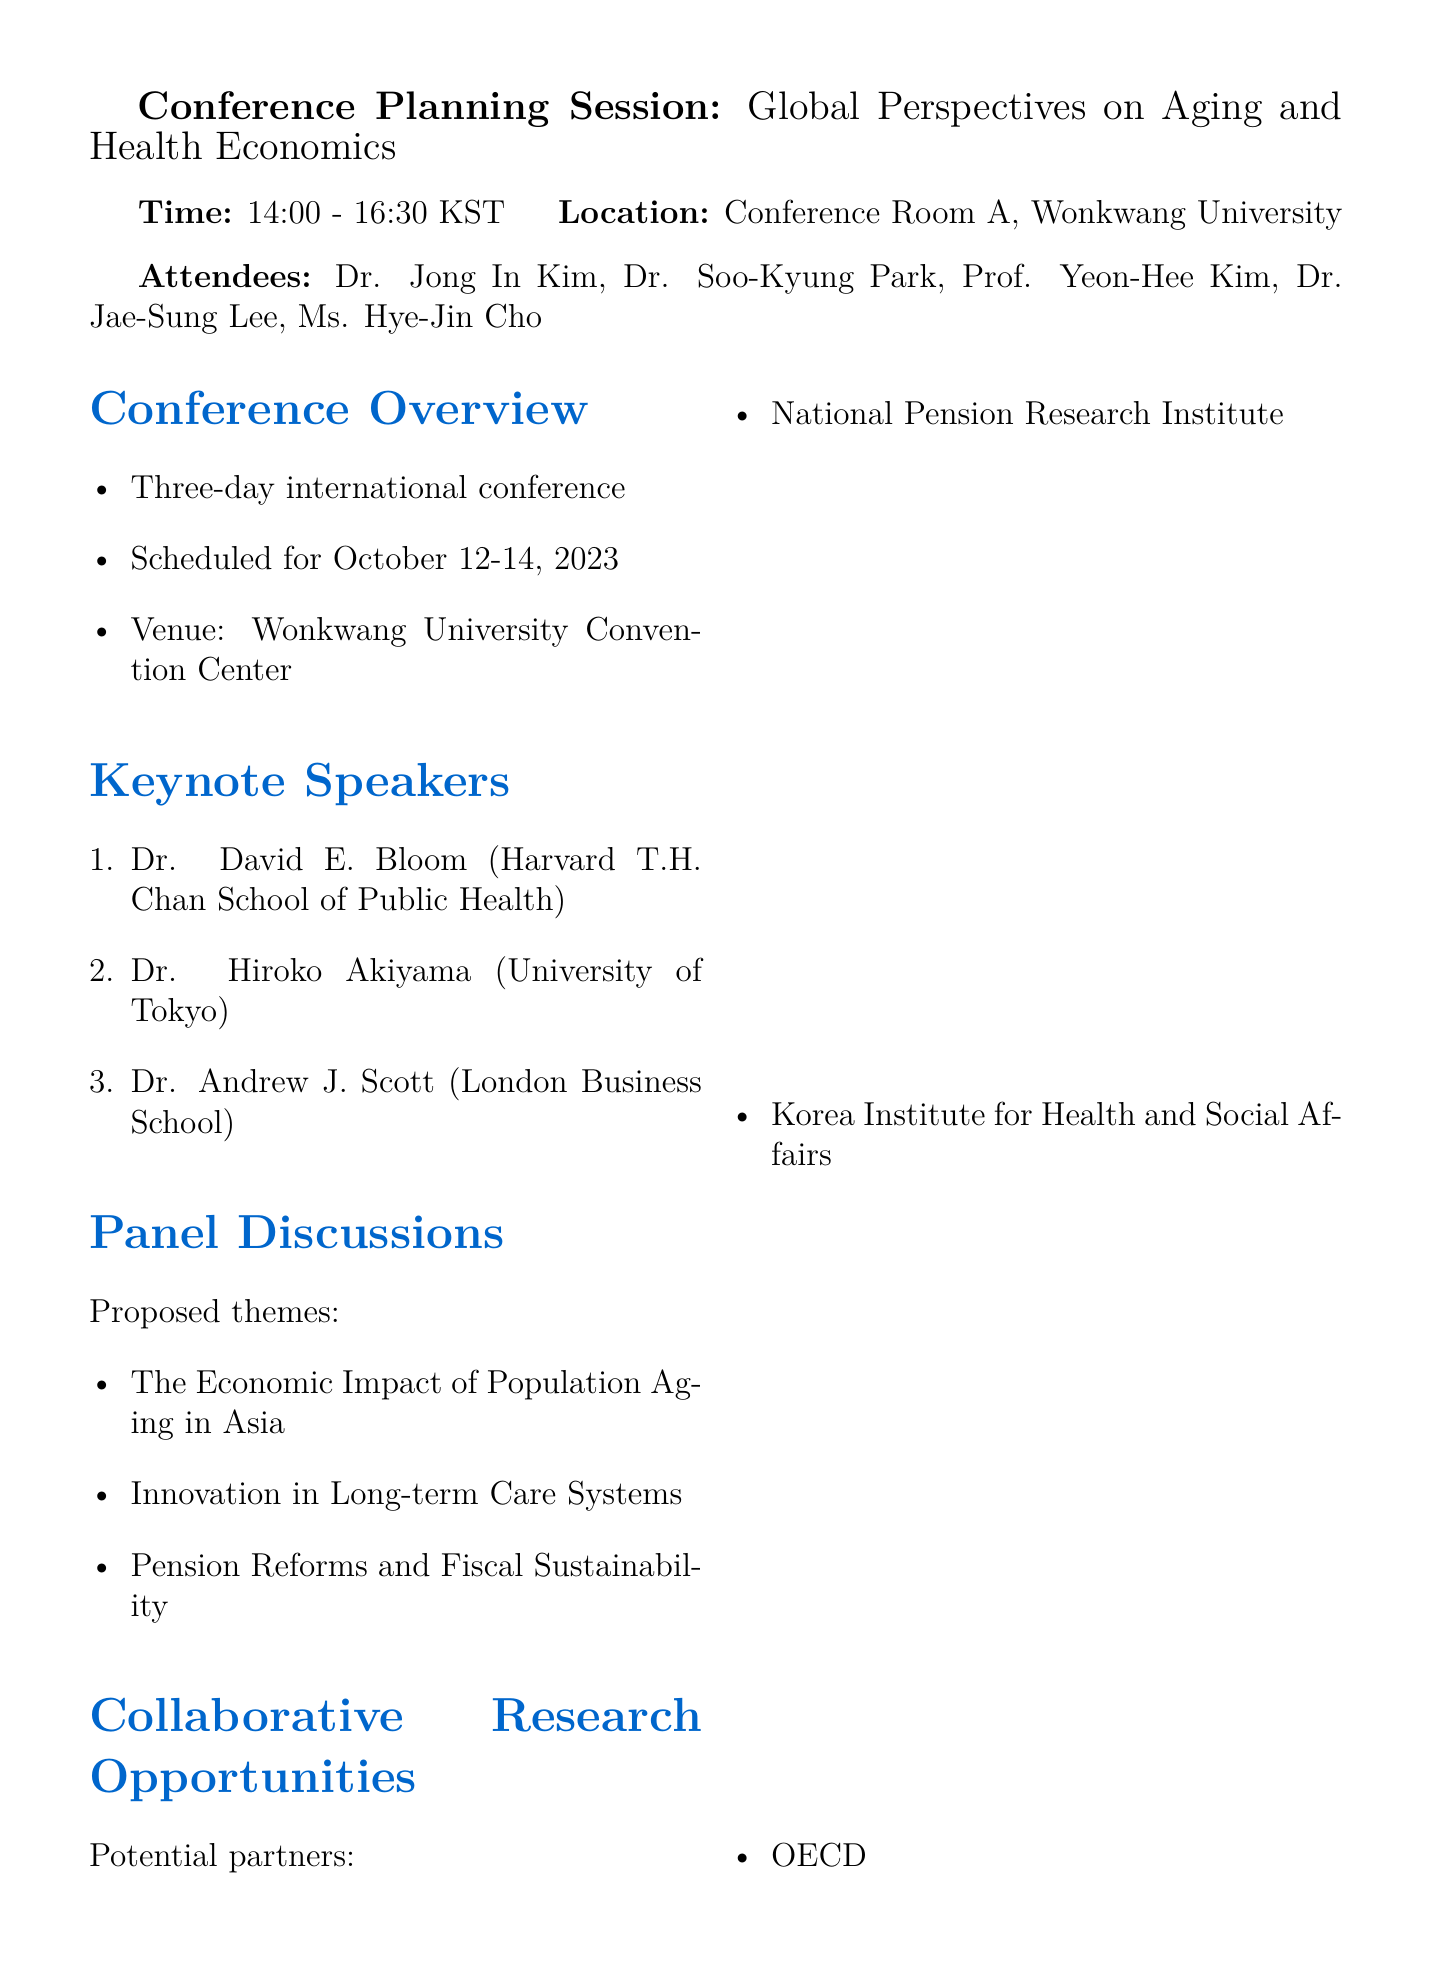What are the conference dates? The conference is scheduled for October 12-14, 2023, as stated in the conference overview section.
Answer: October 12-14, 2023 Who is one of the keynote speakers from Harvard? The document lists Dr. David E. Bloom from Harvard T.H. Chan School of Public Health as a keynote speaker.
Answer: Dr. David E. Bloom What is the total budget allocated for the conference? The budget allocation section specifies the total budget as ₩150,000,000.
Answer: ₩150,000,000 Which organization is mentioned as a potential research partner? The document lists National Pension Research Institute as one of the potential partners in the collaborative research opportunities section.
Answer: National Pension Research Institute What is one of the proposed panel discussion themes? The document mentions "The Economic Impact of Population Aging in Asia" as a proposed theme in the panel discussions section.
Answer: The Economic Impact of Population Aging in Asia When is the deadline to finalize the conference program? The action items explicitly state that the conference program needs to be finalized by June 30.
Answer: June 30 Who chaired the meeting? The attendees section includes Dr. Jong In Kim, indicating his role in leading the meeting.
Answer: Dr. Jong In Kim Where will the conference be held? The venue indicated in the document for the conference is the Wonkwang University Convention Center.
Answer: Wonkwang University Convention Center 